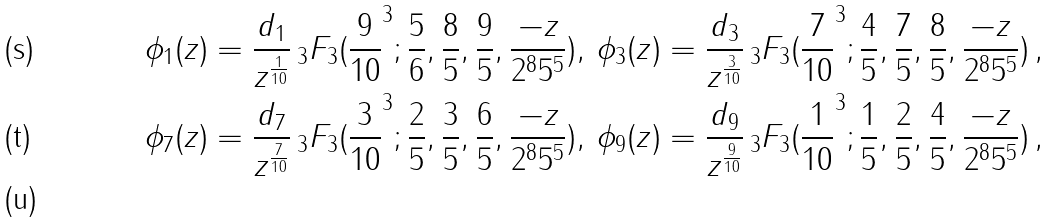<formula> <loc_0><loc_0><loc_500><loc_500>& \phi _ { 1 } ( z ) = \frac { d _ { 1 } } { z ^ { \frac { 1 } { 1 0 } } } \, _ { 3 } F _ { 3 } ( \frac { 9 } { 1 0 } ^ { 3 } ; \frac { 5 } { 6 } , \frac { 8 } { 5 } , \frac { 9 } { 5 } , \frac { - z } { 2 ^ { 8 } 5 ^ { 5 } } ) , \, \phi _ { 3 } ( z ) = \frac { d _ { 3 } } { z ^ { \frac { 3 } { 1 0 } } } \, _ { 3 } F _ { 3 } ( \frac { 7 } { 1 0 } ^ { 3 } ; \frac { 4 } { 5 } , \frac { 7 } { 5 } , \frac { 8 } { 5 } , \frac { - z } { 2 ^ { 8 } 5 ^ { 5 } } ) \, , \, \\ & \phi _ { 7 } ( z ) = \frac { d _ { 7 } } { z ^ { \frac { 7 } { 1 0 } } } \, _ { 3 } F _ { 3 } ( \frac { 3 } { 1 0 } ^ { 3 } ; \frac { 2 } { 5 } , \frac { 3 } { 5 } , \frac { 6 } { 5 } , \frac { - z } { 2 ^ { 8 } 5 ^ { 5 } } ) , \, \phi _ { 9 } ( z ) = \frac { d _ { 9 } } { z ^ { \frac { 9 } { 1 0 } } } \, _ { 3 } F _ { 3 } ( \frac { 1 } { 1 0 } ^ { 3 } ; \frac { 1 } { 5 } , \frac { 2 } { 5 } , \frac { 4 } { 5 } , \frac { - z } { 2 ^ { 8 } 5 ^ { 5 } } ) \, , \, \\</formula> 